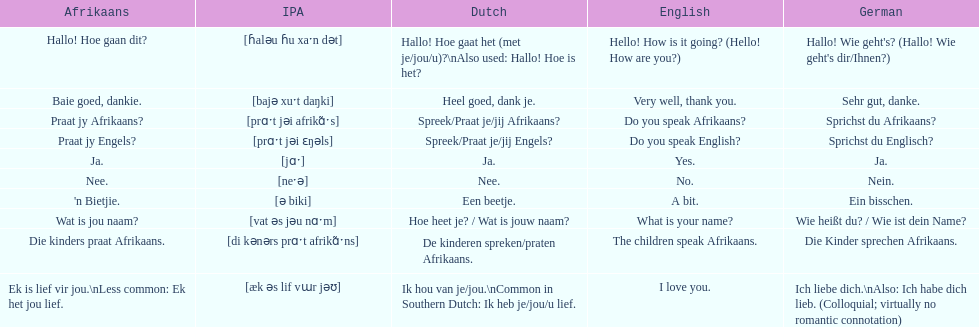Convert the following into english: 'n bietjie. A bit. 